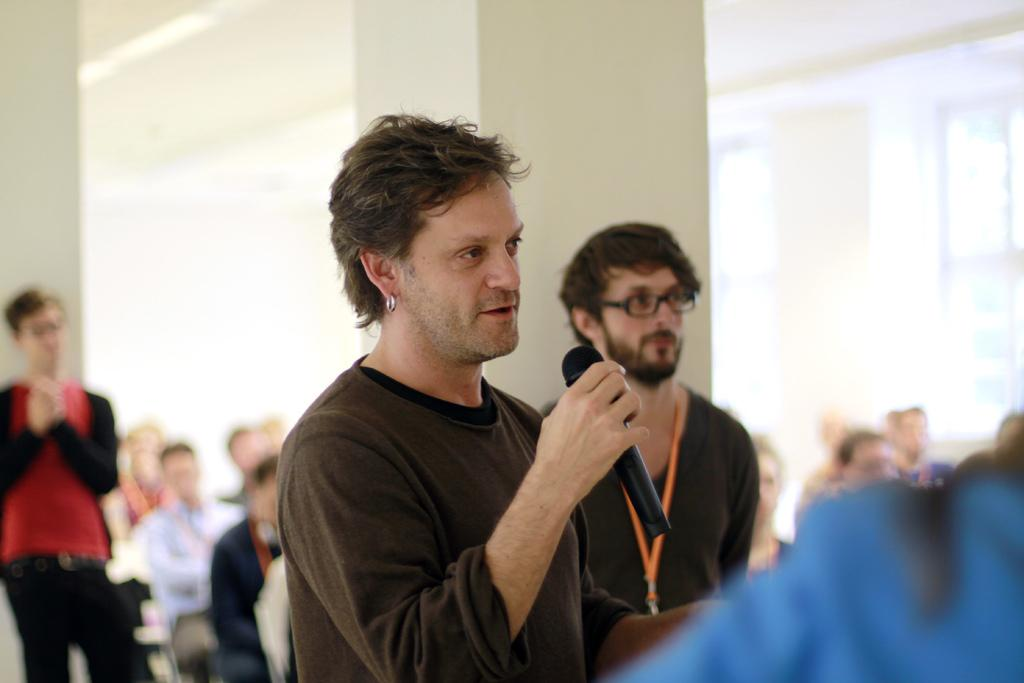What is present in the background of the image? There is a wall in the image. What are the people in the image doing? There are people standing and sitting in the image. Can you describe the man in the front of the image? The man in the front of the image is standing and holding a mic. How many icicles are hanging from the wall in the image? There are no icicles present in the image; it features a wall with people standing and sitting. What type of iron is being used by the people in the image? There is no iron present in the image; people are standing and sitting, and a man is holding a mic. 